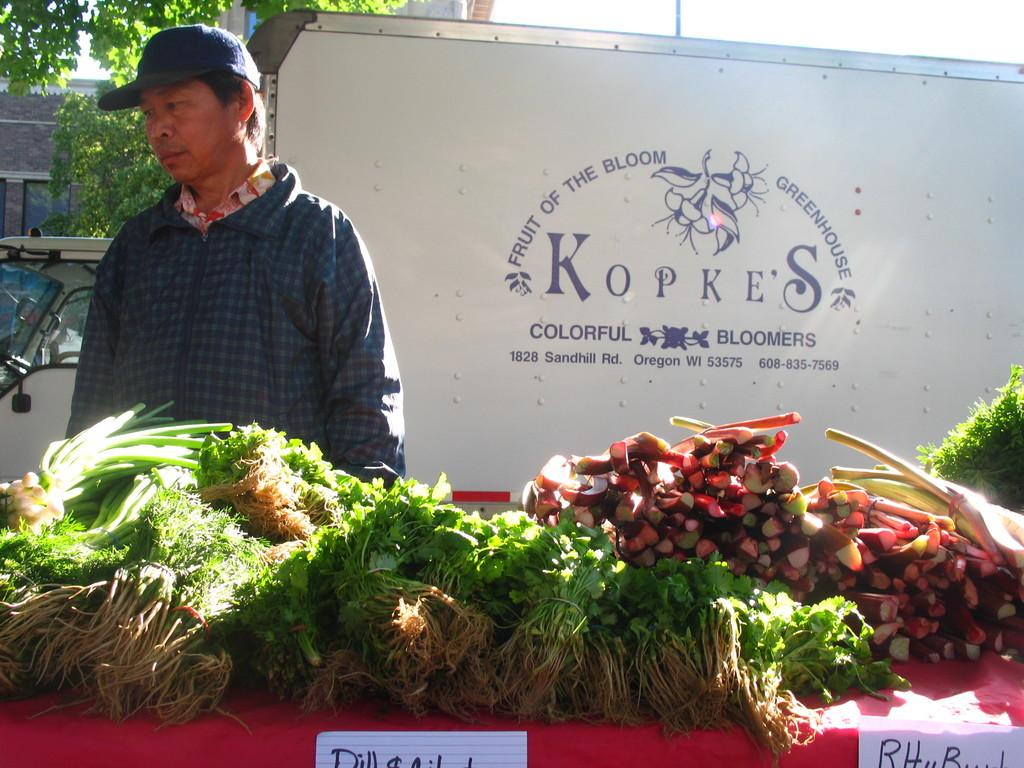What is the main object in the image? There is a table in the image. What is on the table? Leafy vegetables are present on the table. What can be seen in the background of the image? There is a man, a board, and a tree in the background of the image. What type of liquid is being poured by the man in the background of the image? There is no man pouring liquid in the image; the man in the background is not performing any action with a liquid. 